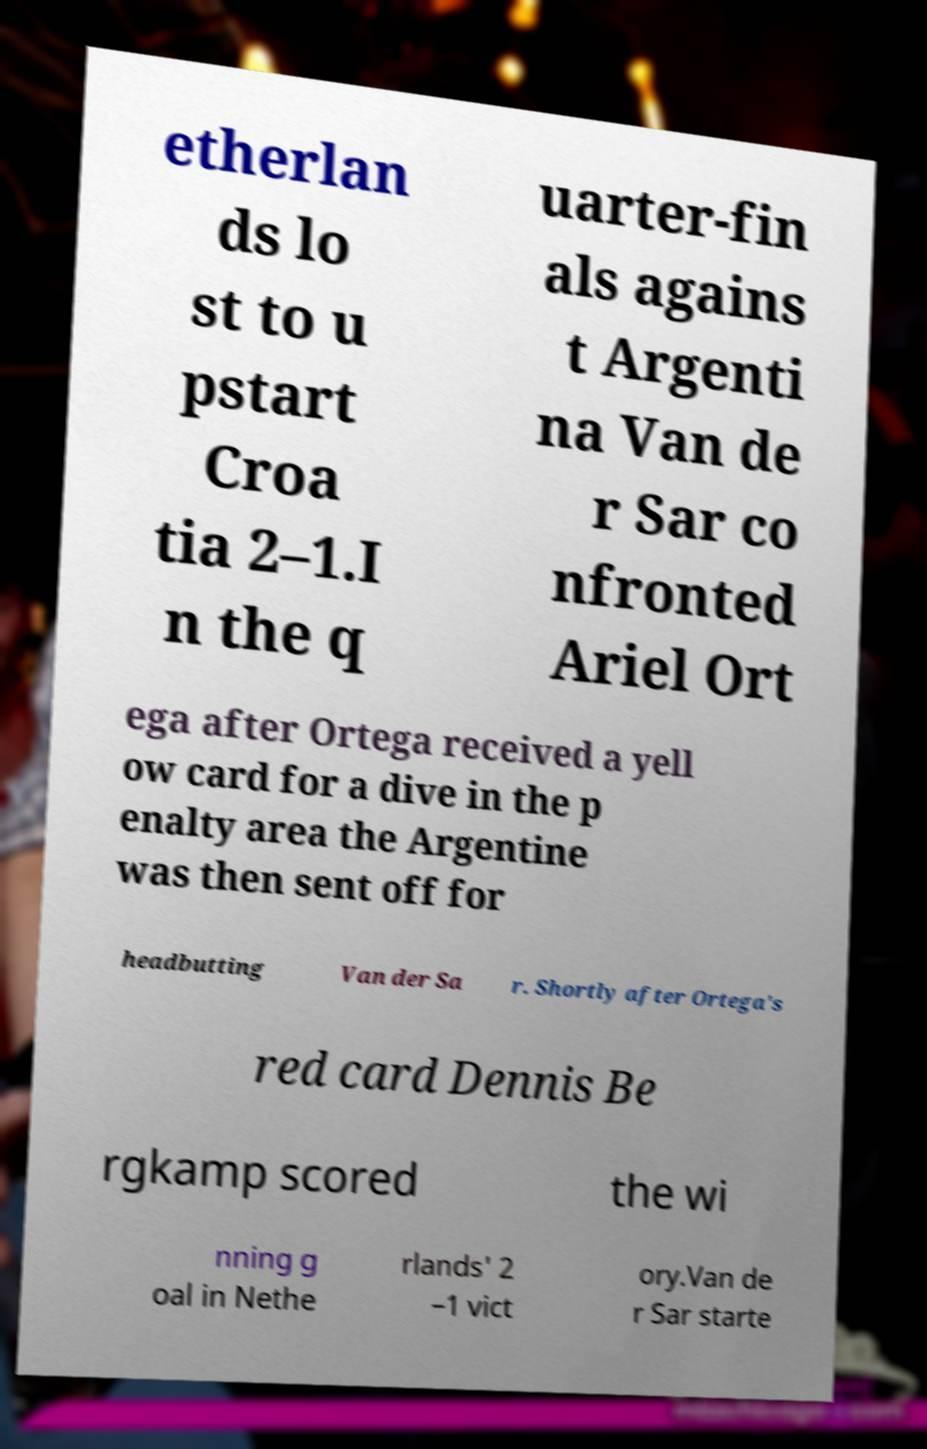I need the written content from this picture converted into text. Can you do that? etherlan ds lo st to u pstart Croa tia 2–1.I n the q uarter-fin als agains t Argenti na Van de r Sar co nfronted Ariel Ort ega after Ortega received a yell ow card for a dive in the p enalty area the Argentine was then sent off for headbutting Van der Sa r. Shortly after Ortega's red card Dennis Be rgkamp scored the wi nning g oal in Nethe rlands' 2 –1 vict ory.Van de r Sar starte 